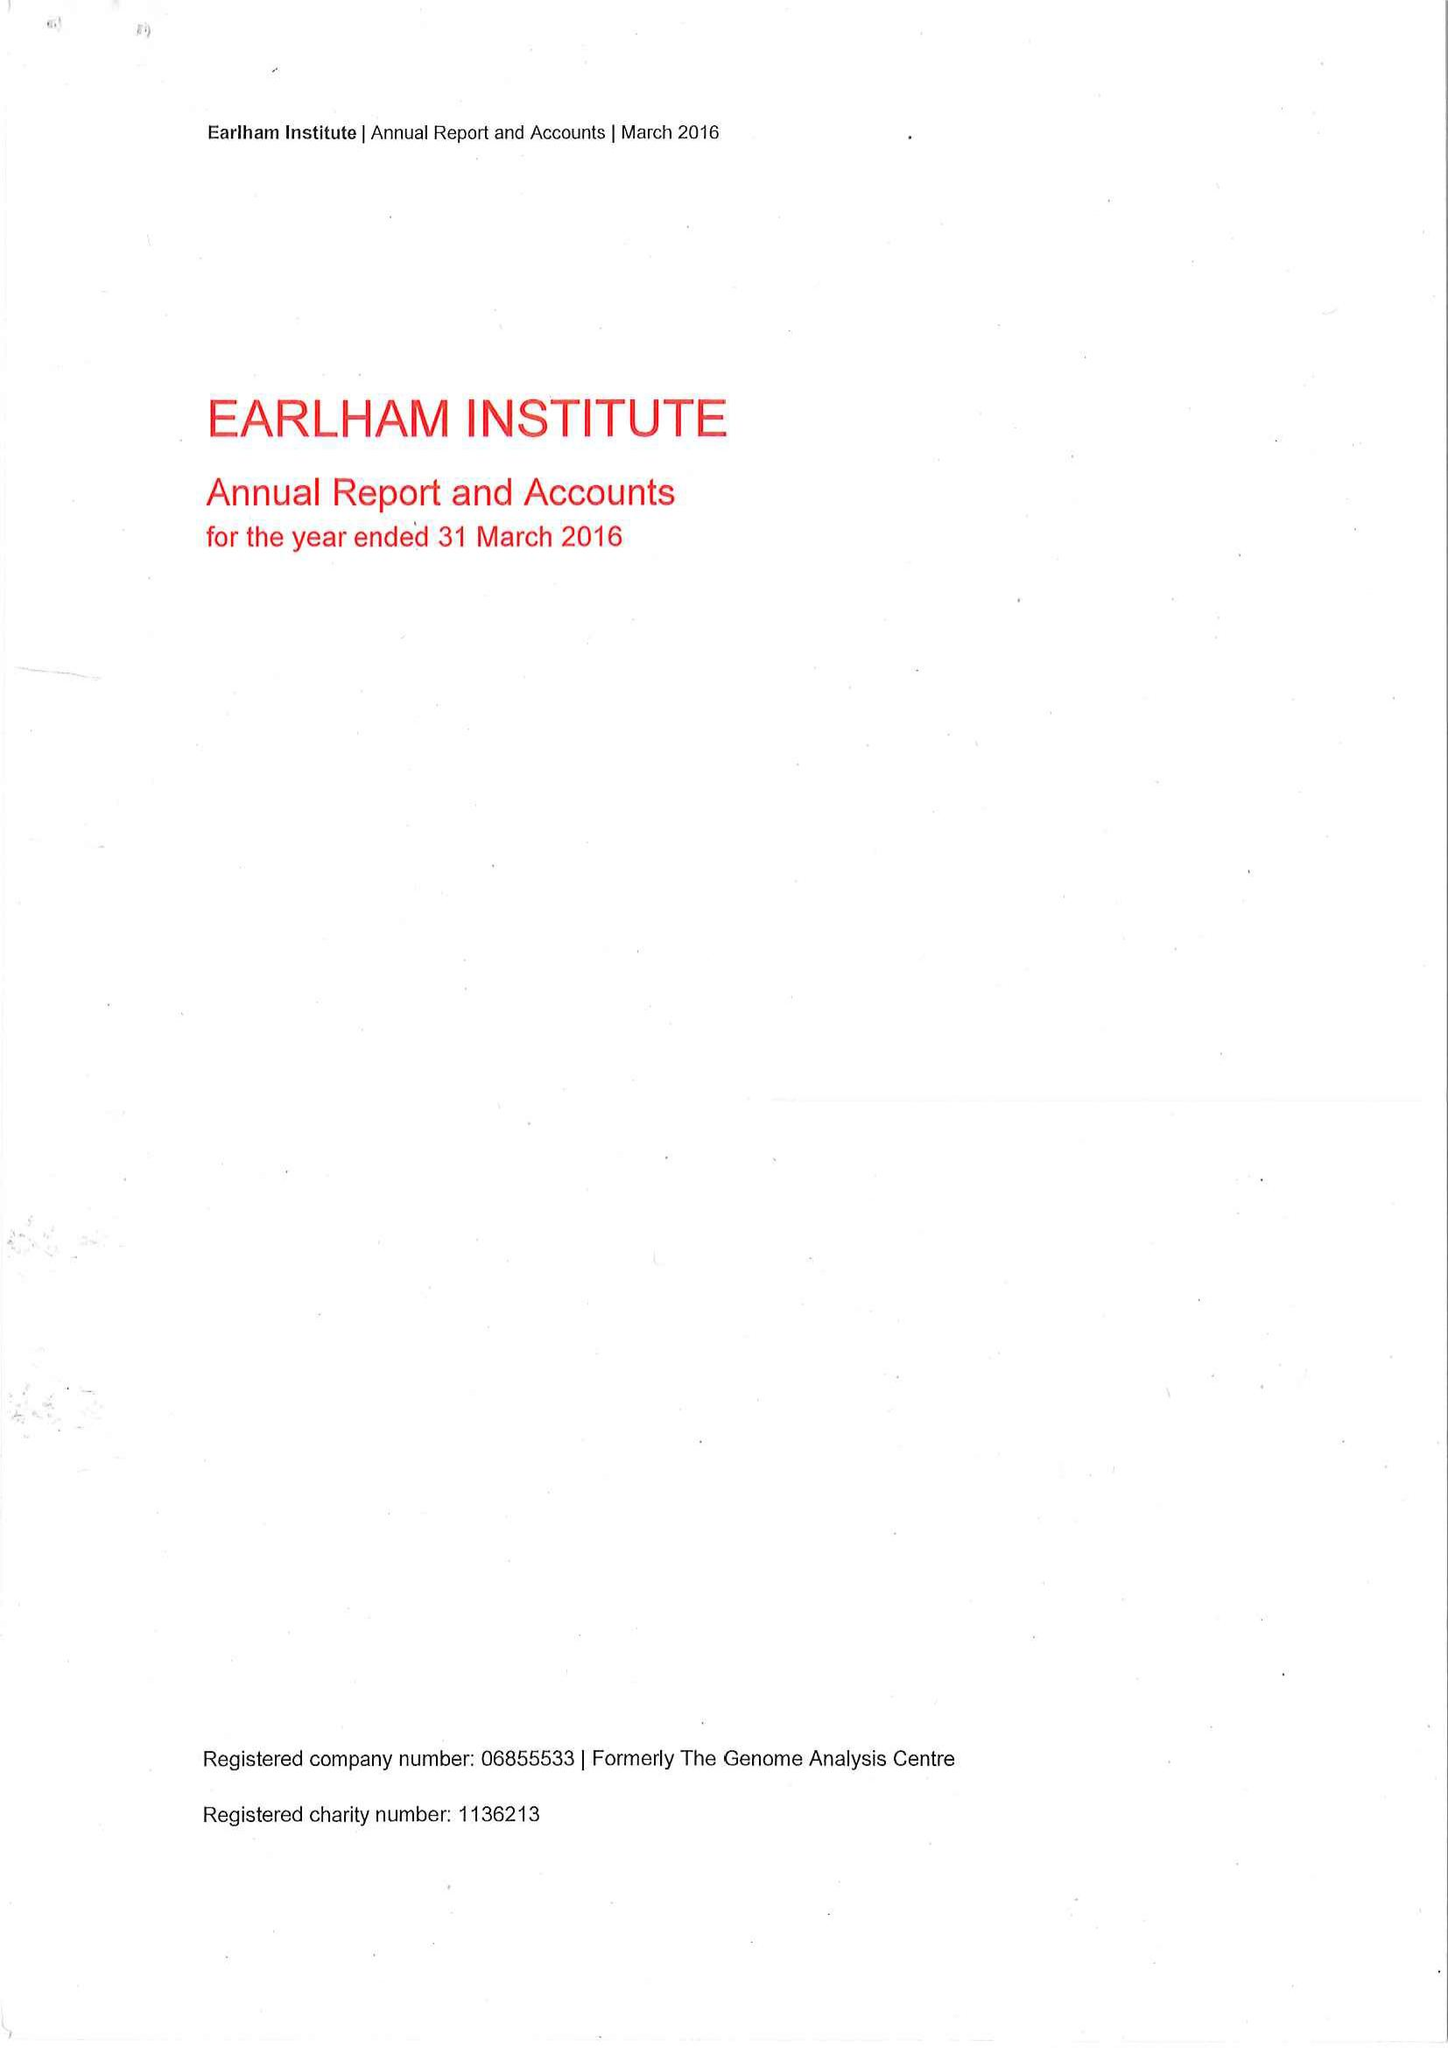What is the value for the charity_name?
Answer the question using a single word or phrase. Earlham Institute 